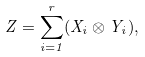<formula> <loc_0><loc_0><loc_500><loc_500>Z = \sum _ { i = 1 } ^ { r } ( X _ { i } \otimes Y _ { i } ) ,</formula> 